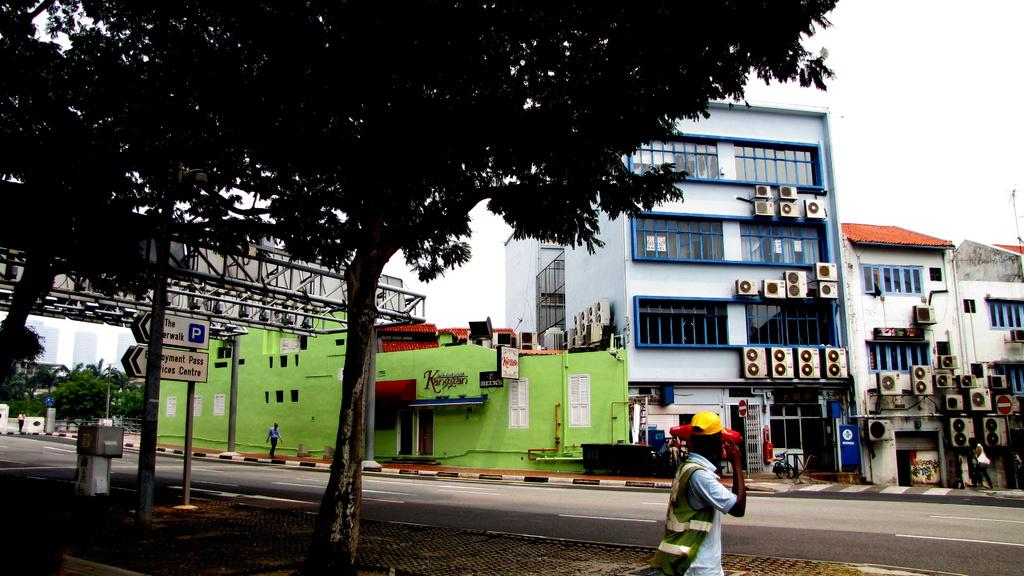What is happening on the road in the image? There are people on the road in the image. What can be seen beside the road in the image? There are trees beside the road in the image. What type of structure is present in the image? There is at least one building in the image. What can be seen on the buildings in the image? Air conditioning units (AC's) are fitted on the buildings in the image. Where is the throne located in the image? There is no throne present in the image. Is there a river flowing beside the road in the image? There is no river visible in the image; only trees are mentioned beside the road. 